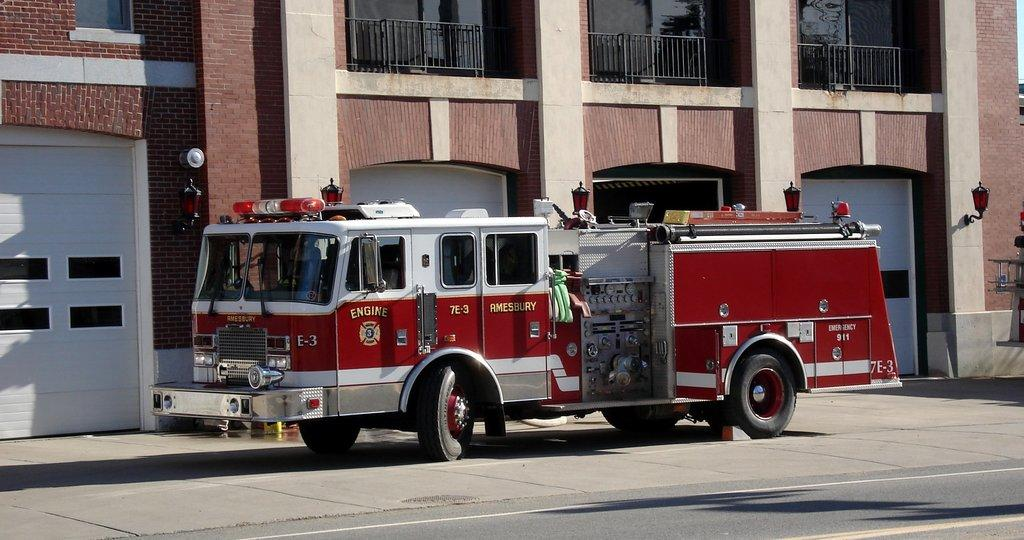What is the main subject of the image? The main subject of the image is a fire engine on the road. What can be seen in the background of the image? There is a building in the background of the image. What features does the building have? The building has doors, iron grilles, and lamps attached to its wall. What is the rate of the fire engine's speed in the image? The image does not provide information about the speed of the fire engine, so we cannot determine its rate. 